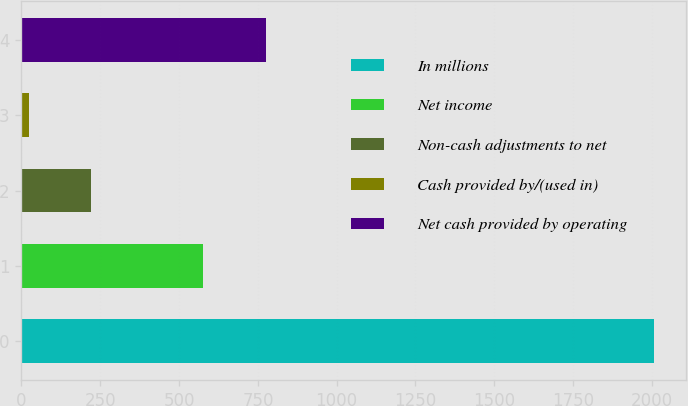Convert chart to OTSL. <chart><loc_0><loc_0><loc_500><loc_500><bar_chart><fcel>In millions<fcel>Net income<fcel>Non-cash adjustments to net<fcel>Cash provided by/(used in)<fcel>Net cash provided by operating<nl><fcel>2008<fcel>576.1<fcel>221.68<fcel>23.2<fcel>774.58<nl></chart> 